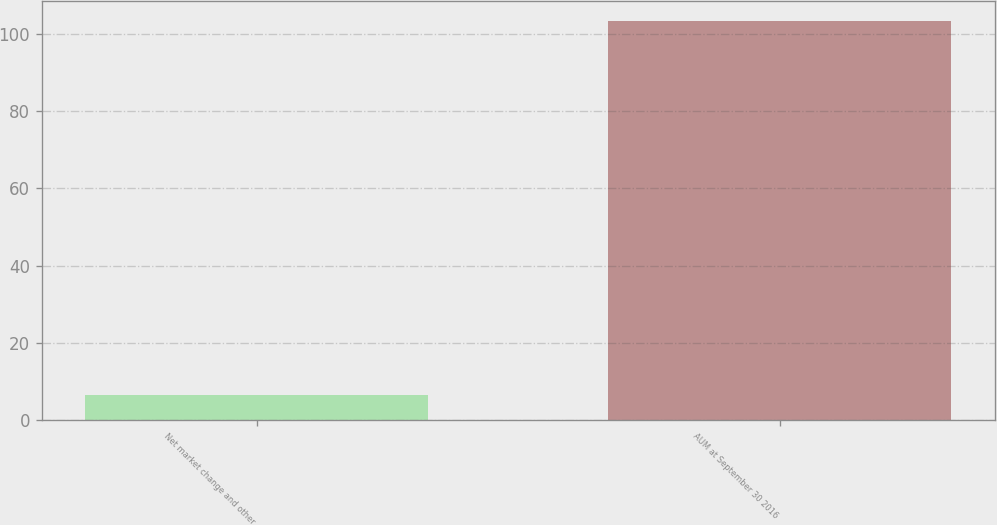<chart> <loc_0><loc_0><loc_500><loc_500><bar_chart><fcel>Net market change and other<fcel>AUM at September 30 2016<nl><fcel>6.5<fcel>103.3<nl></chart> 